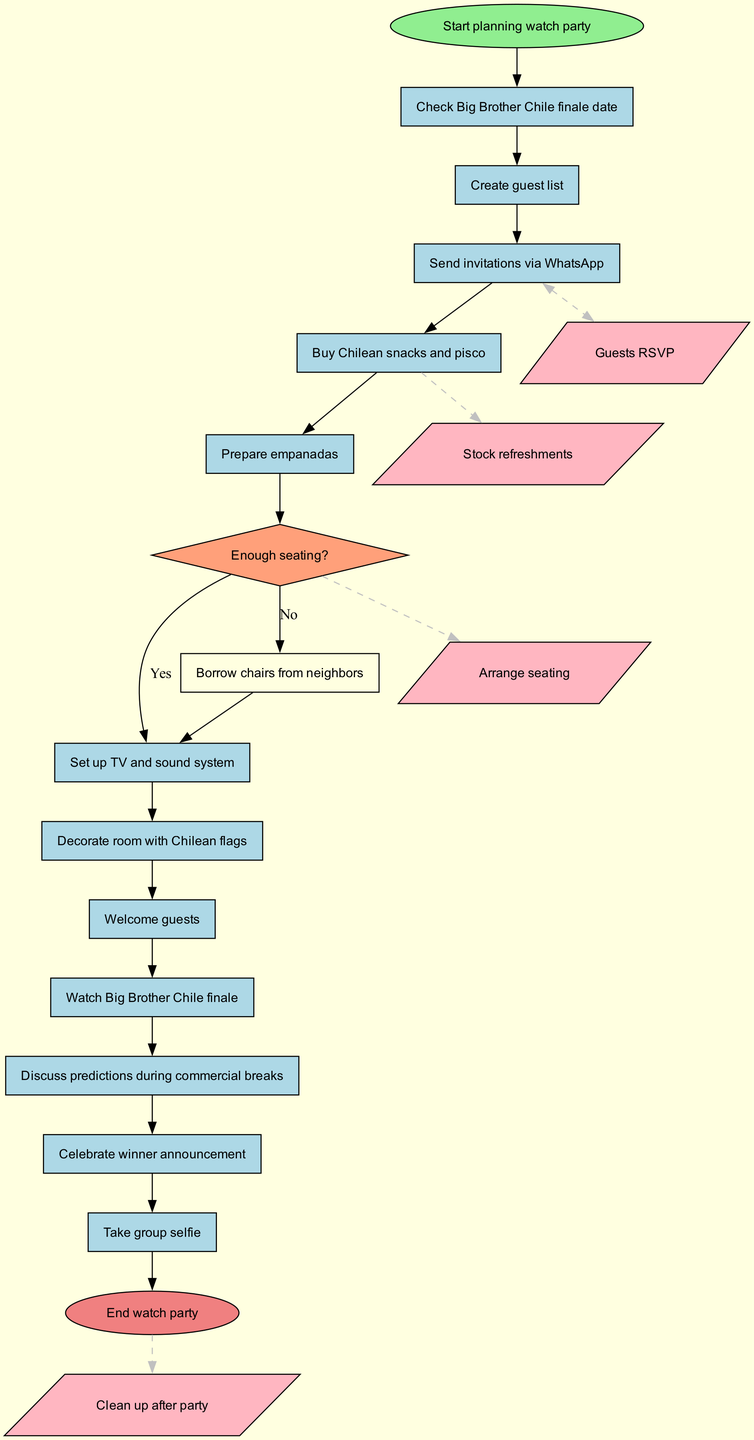What is the initial node of the diagram? The initial node is labeled as "Start planning watch party." This is the first step in the activity sequence represented in the diagram.
Answer: Start planning watch party How many activities are listed in the diagram? The diagram contains a total of 12 activities listed. Each activity is its own step in the process from planning to executing the watch party.
Answer: 12 What happens if there is not enough seating? According to the decision node labeled "Enough seating?", if the answer is no, then the next step is to "Borrow chairs from neighbors." This is a direct consequence when seating is insufficient.
Answer: Borrow chairs from neighbors What activity comes after sending invitations via WhatsApp? Following the activity "Send invitations via WhatsApp," the next activity in the sequence is to "Prepare empanadas." This indicates that preparation continues after invitations are sent.
Answer: Prepare empanadas How is the RSVP process represented in the diagram? The RSVP process is shown as a dashed edge leading to the node labeled "Guests RSVP," indicating a two-way interaction regarding guest confirmations.
Answer: Guests RSVP 